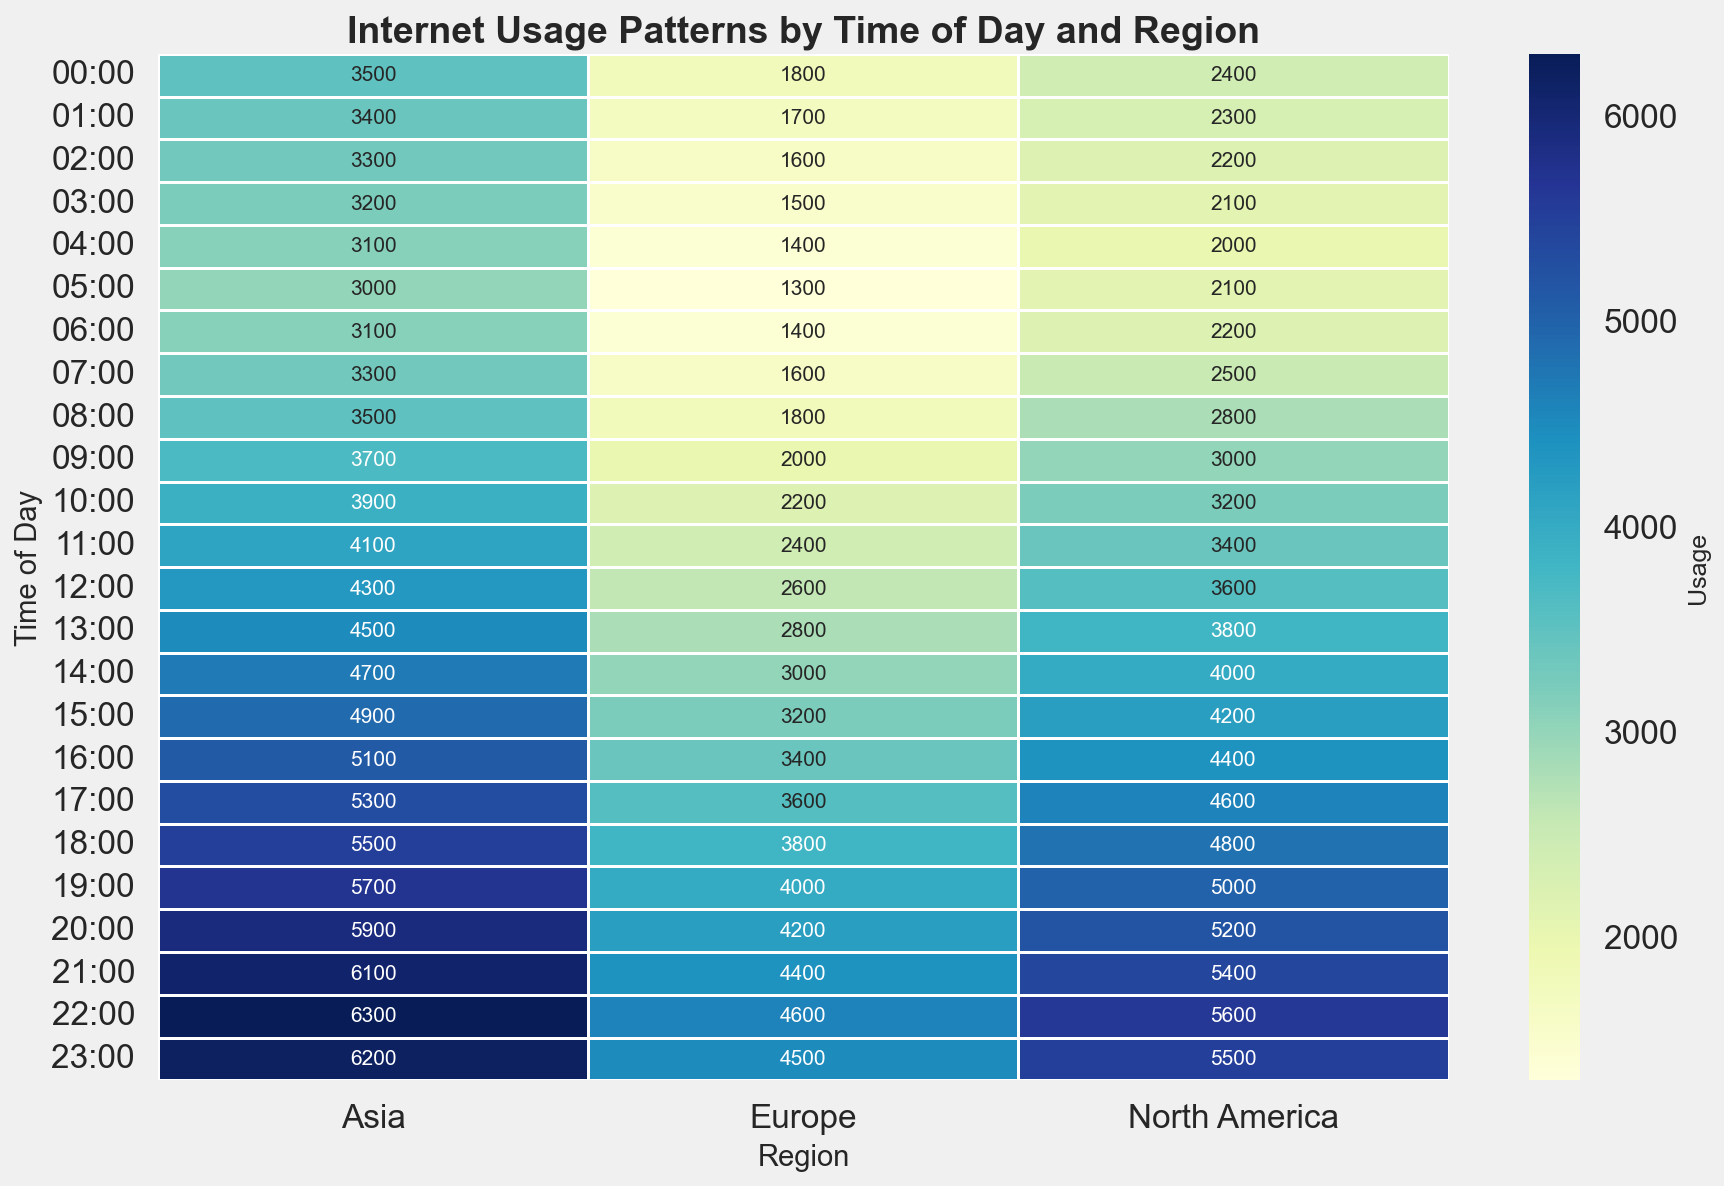Which region has the highest internet usage at 18:00? Look at the row corresponding to 18:00 and compare the values across the regions: North America has 4800, Europe has 3800, and Asia has 5500.
Answer: Asia What is the average internet usage in North America from 14:00 to 16:00? Sum the values from 14:00 to 16:00 in North America: 4000 (14:00) + 4200 (15:00) + 4400 (16:00). The sum is 12600. Since there are three hours, the average is 12600/3 = 4200.
Answer: 4200 Which region has the least variation in internet usage throughout the day? Compare the range of usage values for each region by looking at the gaps between their maximum and minimum values. North America ranges from 2000 to 5600, Europe from 1300 to 4600, and Asia from 3000 to 6300. Europe has the smallest range (3300).
Answer: Europe What time of day is internet usage highest in all regions combined? Add up the usage values for each time across all regions and find the time with the highest combined usage: 2400 + 1800 + 3500 = 7700 (00:00) and so forth. The highest combined usage happens at 22:00 (5600 + 4600 + 6300 = 16500).
Answer: 22:00 Which region shows the steepest increase in internet usage from 06:00 to 12:00? Calculate the difference between 12:00 and 06:00 for each region: North America (3600 - 2200 = 1400), Europe (2600 - 1400 = 1200), and Asia (4300 - 3100 = 2000). Asia has the steepest increase.
Answer: Asia How does internet usage in Europe at 11:00 compare to that at 23:00? Look at the 11:00 row and the 23:00 row in the Europe column. Europe has 2400 at 11:00 and 4500 at 23:00.
Answer: 23:00 > 11:00 If Asia's internet usage continues to follow the same trend, what would you predict for the usage at 24:00 based on the current pattern? Based on the upward trend seen from the data (increasing usage by roughly 100 each hour), the next hour (24:00) could see the internet usage around 6200 + 100 = 6300.
Answer: 6300 Which region's internet usage shows the smoothest transition without sharp spikes or drops? Visually inspect the transition in color shades for each region. North America and Asia exhibit gradual changes while Europe shows a consistent but smaller increase. Europe has the smoothest transitions visually.
Answer: Europe 